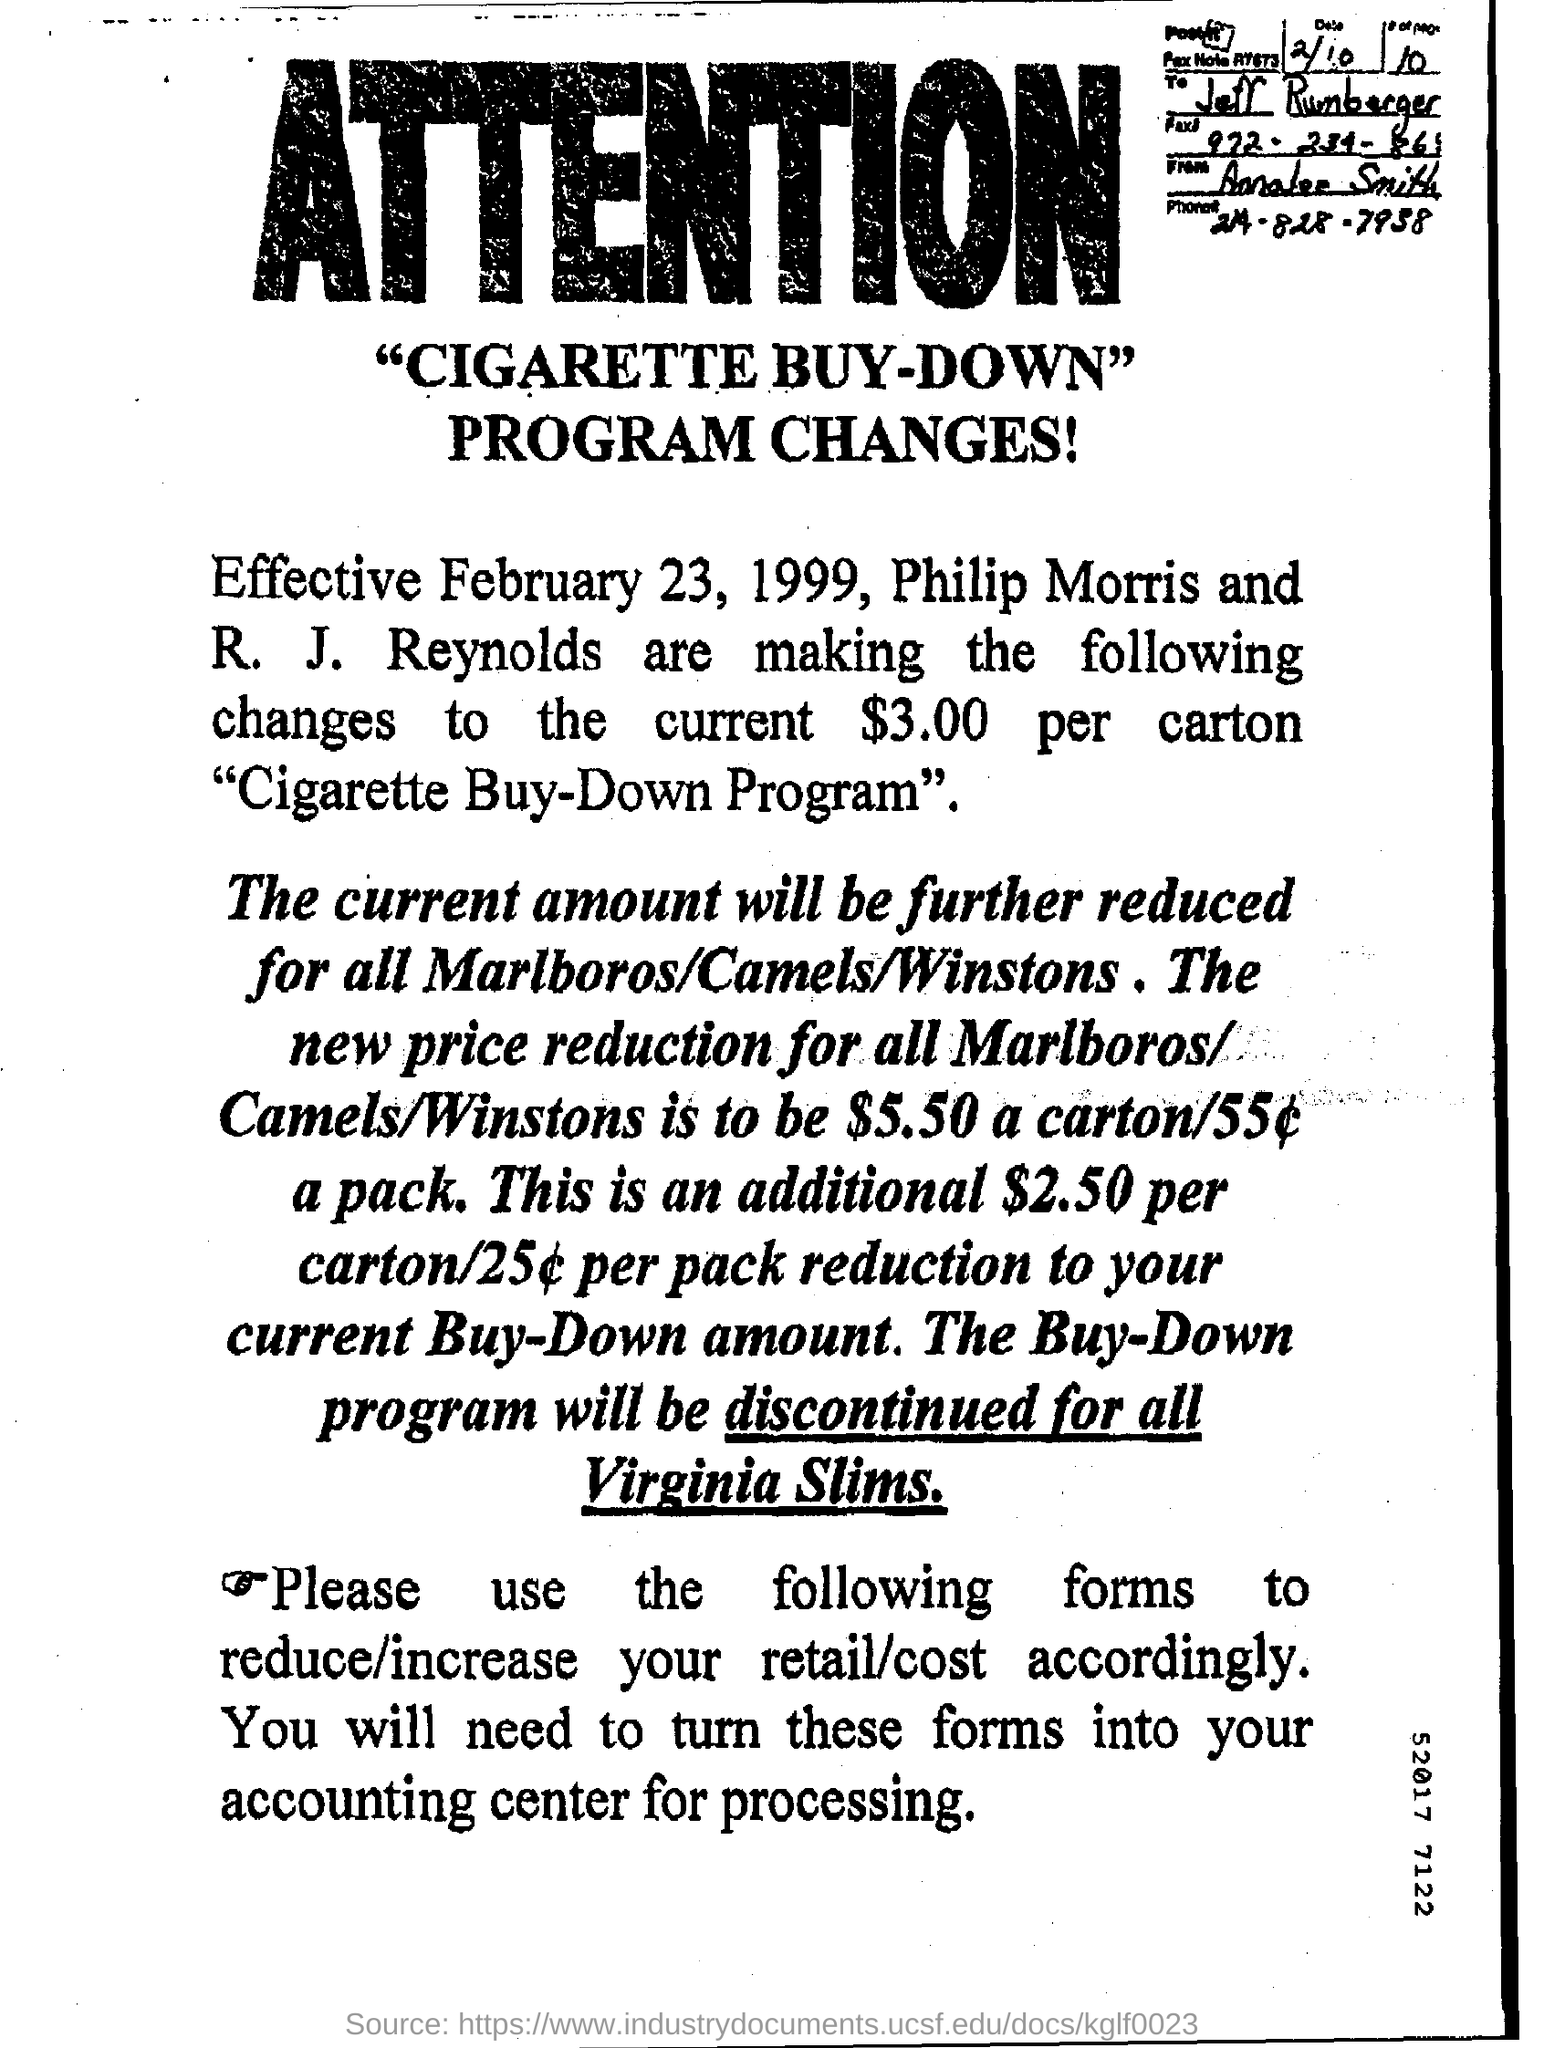Give some essential details in this illustration. The phone number mentioned is 214-828-7938. 